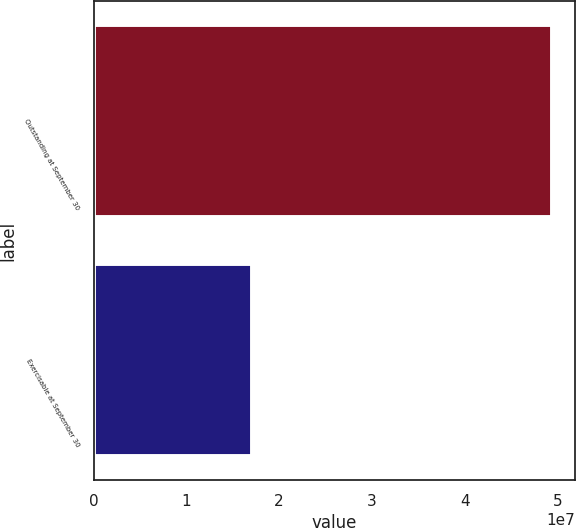<chart> <loc_0><loc_0><loc_500><loc_500><bar_chart><fcel>Outstanding at September 30<fcel>Exercisable at September 30<nl><fcel>4.9479e+07<fcel>1.7058e+07<nl></chart> 